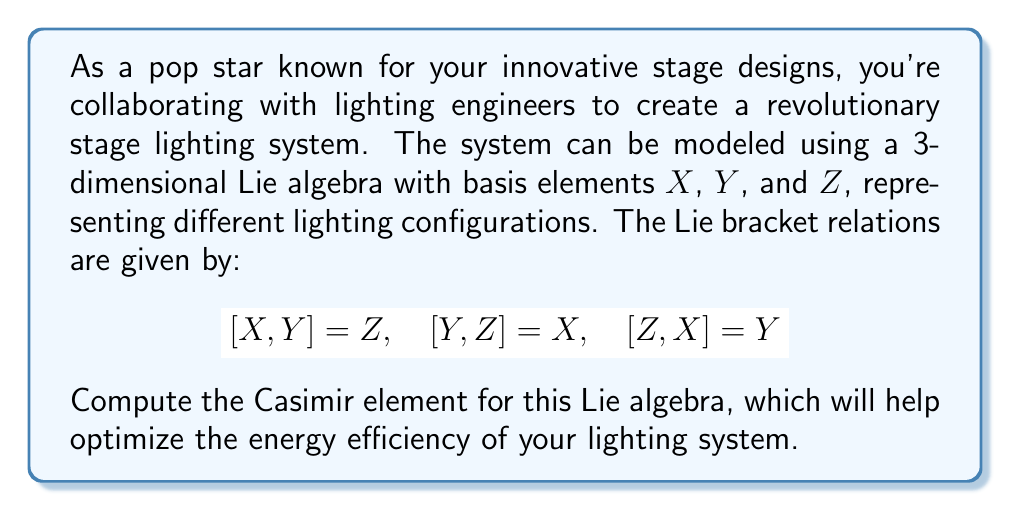Provide a solution to this math problem. To compute the Casimir element for this Lie algebra, we'll follow these steps:

1) First, we need to find the Killing form. For a Lie algebra with basis elements $e_i$ and structure constants $c_{ij}^k$, the Killing form is given by:

   $$B(e_i, e_j) = c_{im}^k c_{jk}^m$$

2) In our case, the non-zero structure constants are:
   $$c_{12}^3 = 1, \quad c_{23}^1 = 1, \quad c_{31}^2 = 1$$
   $$c_{21}^3 = -1, \quad c_{32}^1 = -1, \quad c_{13}^2 = -1$$

3) Let's compute the Killing form:
   
   $$B(X,X) = c_{12}^3 c_{13}^2 + c_{13}^2 c_{12}^3 = 1 \cdot (-1) + (-1) \cdot 1 = -2$$
   $$B(Y,Y) = c_{21}^3 c_{23}^1 + c_{23}^1 c_{21}^3 = (-1) \cdot 1 + 1 \cdot (-1) = -2$$
   $$B(Z,Z) = c_{31}^2 c_{32}^1 + c_{32}^1 c_{31}^2 = 1 \cdot (-1) + (-1) \cdot 1 = -2$$
   $$B(X,Y) = B(Y,X) = B(X,Z) = B(Z,X) = B(Y,Z) = B(Z,Y) = 0$$

4) The Killing form matrix is thus:
   $$B = \begin{pmatrix} -2 & 0 & 0 \\ 0 & -2 & 0 \\ 0 & 0 & -2 \end{pmatrix}$$

5) The inverse of this matrix is:
   $$B^{-1} = \begin{pmatrix} -1/2 & 0 & 0 \\ 0 & -1/2 & 0 \\ 0 & 0 & -1/2 \end{pmatrix}$$

6) The Casimir element is given by:
   $$C = \sum_{i,j} B^{ij} e_i e_j$$
   where $B^{ij}$ are the elements of the inverse Killing form matrix.

7) Therefore, the Casimir element is:
   $$C = -\frac{1}{2}(X^2 + Y^2 + Z^2)$$
Answer: The Casimir element for the given Lie algebra is:

$$C = -\frac{1}{2}(X^2 + Y^2 + Z^2)$$ 